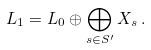<formula> <loc_0><loc_0><loc_500><loc_500>L _ { 1 } = L _ { 0 } \oplus \bigoplus _ { s \in S ^ { \prime } } X _ { s } \, .</formula> 